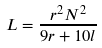Convert formula to latex. <formula><loc_0><loc_0><loc_500><loc_500>L = \frac { r ^ { 2 } N ^ { 2 } } { 9 r + 1 0 l }</formula> 